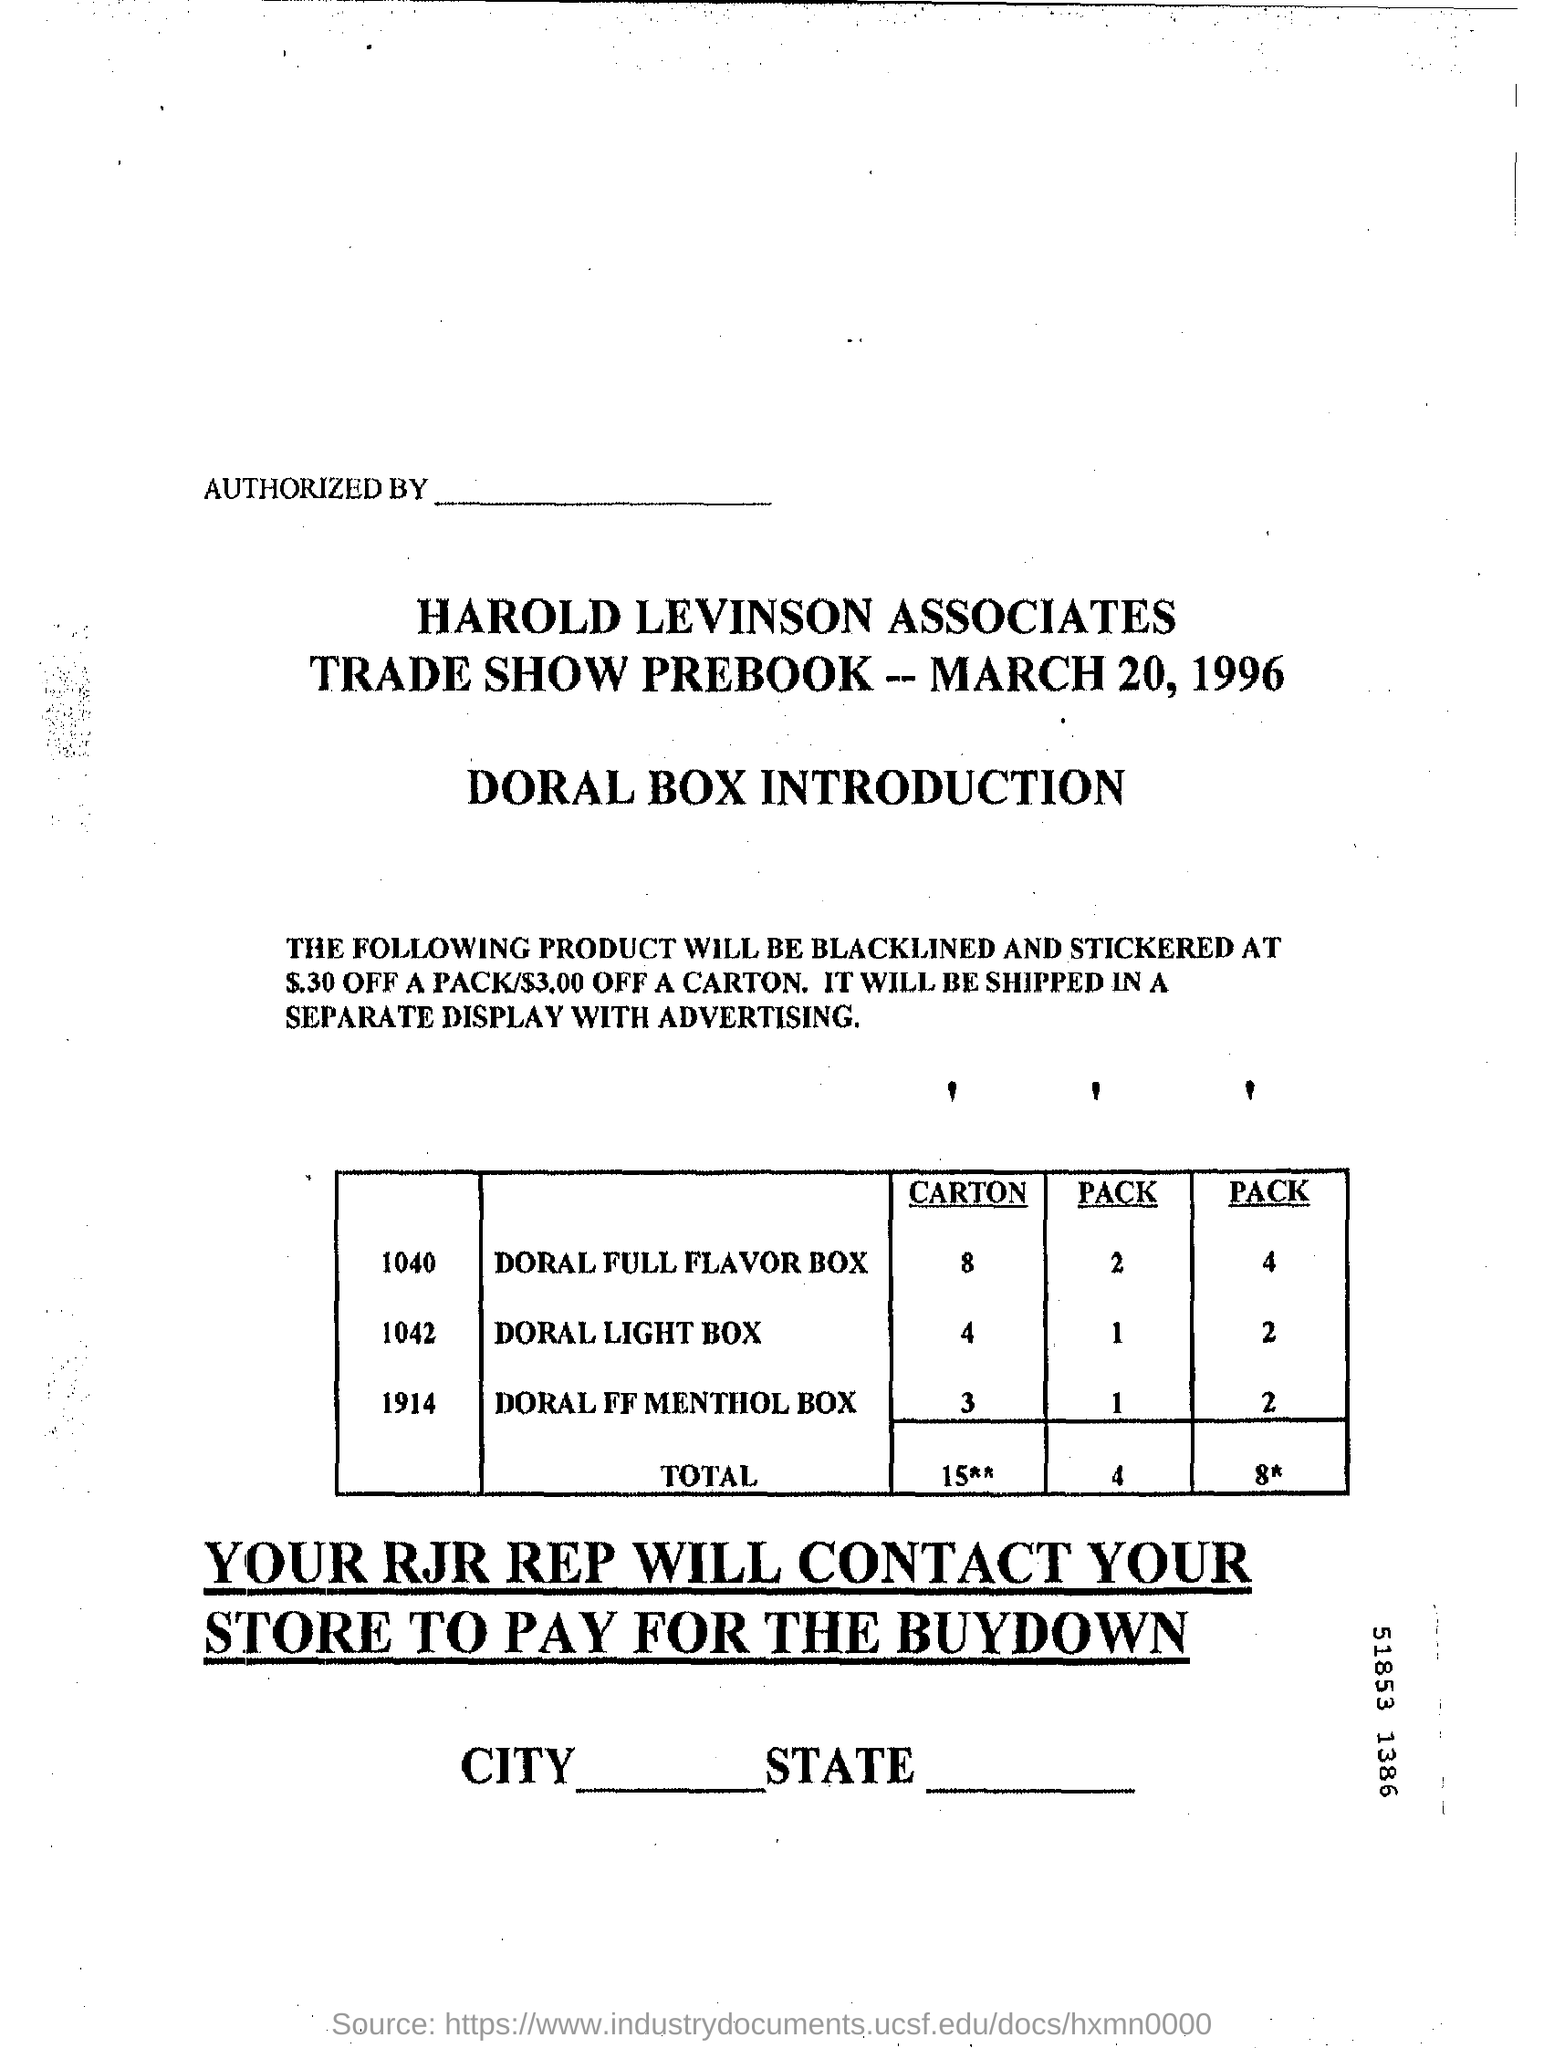Indicate a few pertinent items in this graphic. On March 20, 1996, the date of the trade show prebook was. There are 4 cartons of Doral Light boxes listed in the table. This prebook is that of Harold Levinson Associates. 